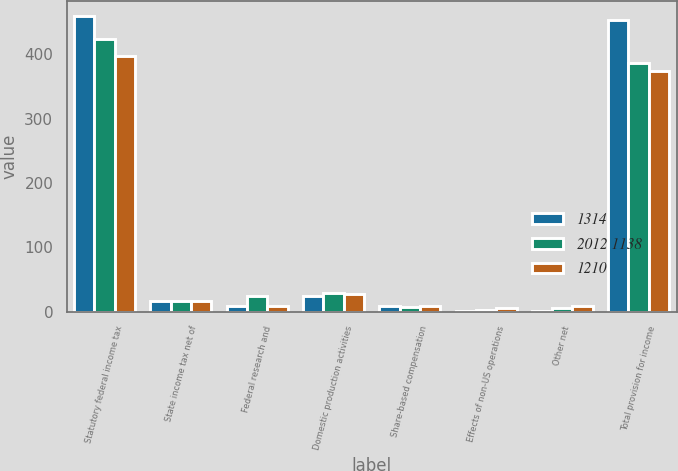<chart> <loc_0><loc_0><loc_500><loc_500><stacked_bar_chart><ecel><fcel>Statutory federal income tax<fcel>State income tax net of<fcel>Federal research and<fcel>Domestic production activities<fcel>Share-based compensation<fcel>Effects of non-US operations<fcel>Other net<fcel>Total provision for income<nl><fcel>1314<fcel>460<fcel>17<fcel>8<fcel>25<fcel>9<fcel>1<fcel>1<fcel>453<nl><fcel>2012 1138<fcel>424<fcel>17<fcel>24<fcel>29<fcel>7<fcel>2<fcel>6<fcel>387<nl><fcel>1210<fcel>398<fcel>16<fcel>8<fcel>27<fcel>8<fcel>5<fcel>8<fcel>374<nl></chart> 